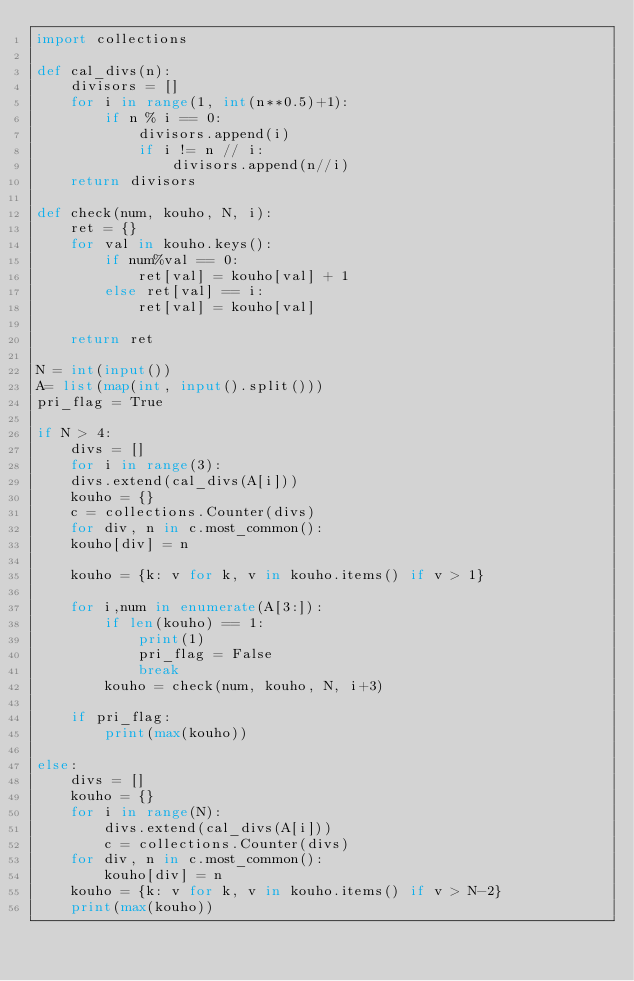Convert code to text. <code><loc_0><loc_0><loc_500><loc_500><_Python_>import collections

def cal_divs(n):
    divisors = []
    for i in range(1, int(n**0.5)+1):
        if n % i == 0:
            divisors.append(i)
            if i != n // i:
                divisors.append(n//i)
    return divisors
  
def check(num, kouho, N, i):
    ret = {}
    for val in kouho.keys():
        if num%val == 0:
            ret[val] = kouho[val] + 1
        else ret[val] == i:
            ret[val] = kouho[val]
        
    return ret
  
N = int(input())
A= list(map(int, input().split()))
pri_flag = True

if N > 4:
    divs = []
    for i in range(3):
    divs.extend(cal_divs(A[i]))
    kouho = {}
    c = collections.Counter(divs)
    for div, n in c.most_common():
    kouho[div] = n

    kouho = {k: v for k, v in kouho.items() if v > 1}

    for i,num in enumerate(A[3:]):
        if len(kouho) == 1:
            print(1)
            pri_flag = False
            break
        kouho = check(num, kouho, N, i+3)
    
    if pri_flag:
        print(max(kouho))
        
else:
    divs = []
    kouho = {}
    for i in range(N):
        divs.extend(cal_divs(A[i]))
        c = collections.Counter(divs)
    for div, n in c.most_common():
        kouho[div] = n
    kouho = {k: v for k, v in kouho.items() if v > N-2}
    print(max(kouho))</code> 